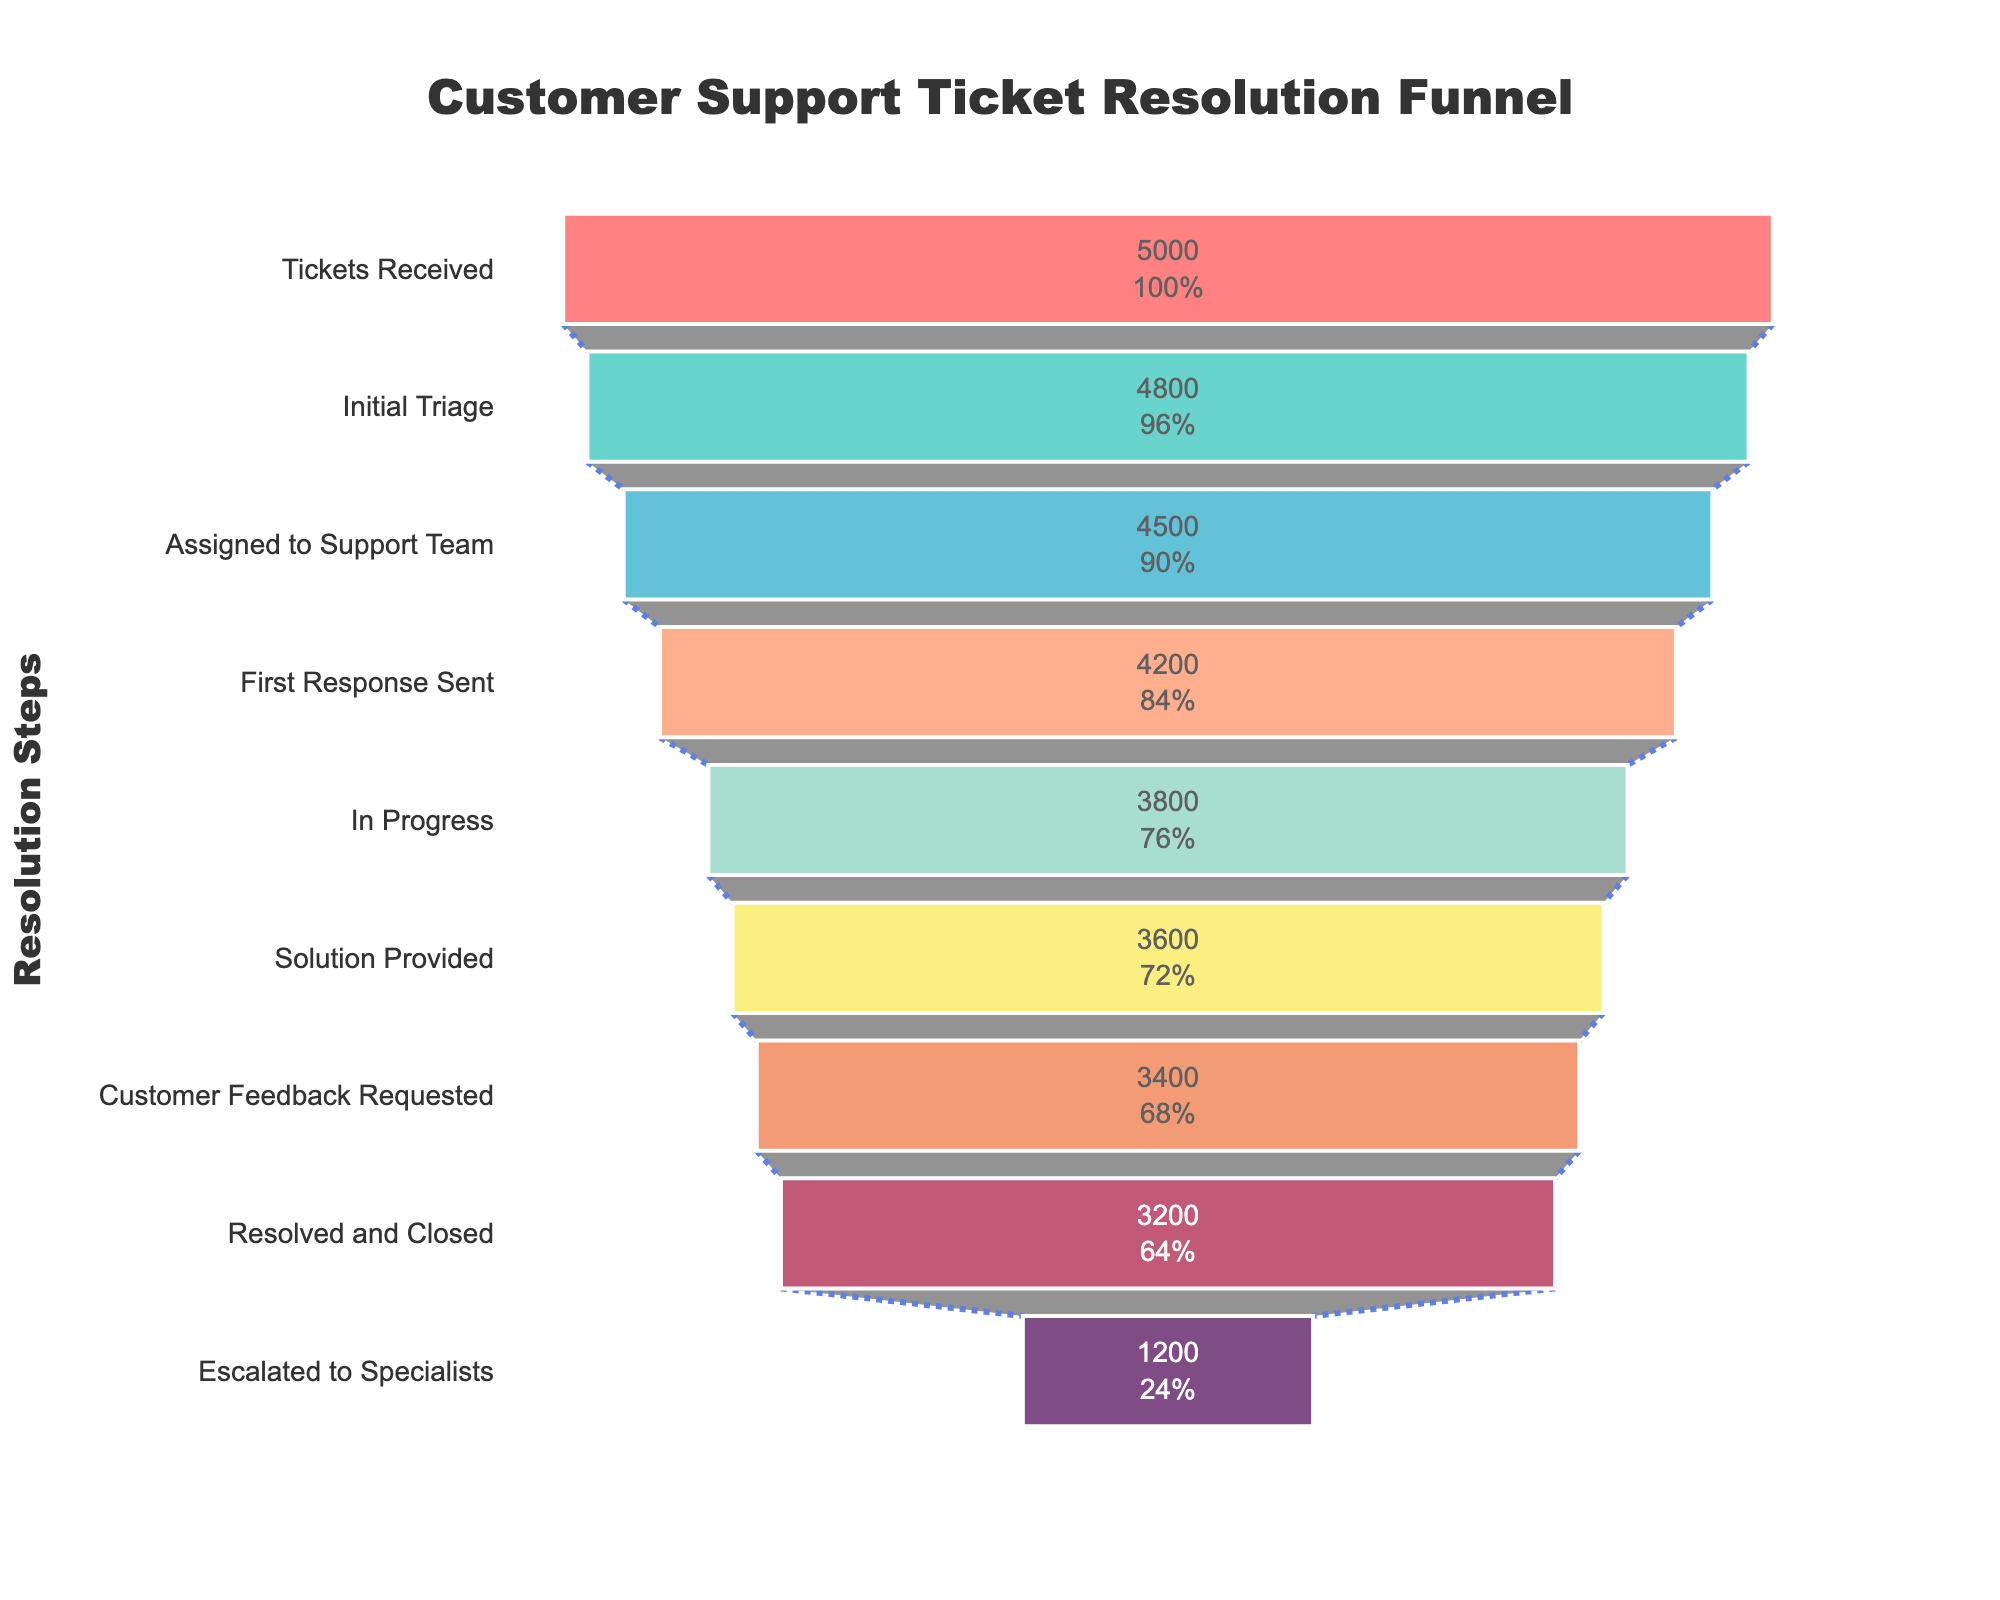What is the title of the chart? The title is located at the top of the chart and is usually the most prominent text. The title provides an overview of what the chart represents.
Answer: Customer Support Ticket Resolution Funnel How many steps does the funnel chart include? Count the number of distinct steps on the y-axis. Each step represents a stage in the ticket resolution process.
Answer: 8 What is the volume of tickets at the "Initial Triage" step? Locate the "Initial Triage" label on the y-axis and look horizontally to see the volume of tickets at this stage.
Answer: 4800 By how many tickets does the volume decrease from "Escalated to Specialists" to "Solution Provided"? Identify the volumes for "Escalated to Specialists" and "Solution Provided" and subtract the "Solution Provided" volume from the "Escalated to Specialists" volume to find the difference.
Answer: 3600 - 1200 = 2400 Which step has the smallest volume of tickets? Compare the volumes of tickets at each step by looking at the x-axis values for each stage. The step with the smallest value represents the smallest volume.
Answer: Escalated to Specialists What percentage of tickets are resolved and closed out of the initial tickets received? Divide the volume of "Resolved and Closed" tickets by the volume of "Tickets Received" and multiply by 100 to get the percentage.
Answer: (3200 / 5000) * 100 = 64% How many more tickets are in the "Assigned to Support Team" step compared to the "Customer Feedback Requested" step? Find the volumes of tickets for both steps and subtract the volume of "Customer Feedback Requested" from the volume of "Assigned to Support Team" to get the difference.
Answer: 4500 - 3400 = 1100 What is the first step in the funnel where the volume drops below 4000 tickets? Identify the step where the volume of tickets is less than 4000 for the first time as you move down the funnel.
Answer: In Progress What is the color of the "Solution Provided" step? Locate the "Solution Provided" step on the funnel and observe the color used to fill this section. This color helps visually differentiate it from other steps.
Answer: "#F08A5D" (Note: This color represents the specific hue in a user-friendly format.) What is the overall decrease in ticket volume from "Tickets Received" to "Resolved and Closed"? Subtract the volume at the "Resolved and Closed" step from the volume at the "Tickets Received" step to find the overall decrease.
Answer: 5000 - 3200 = 1800 